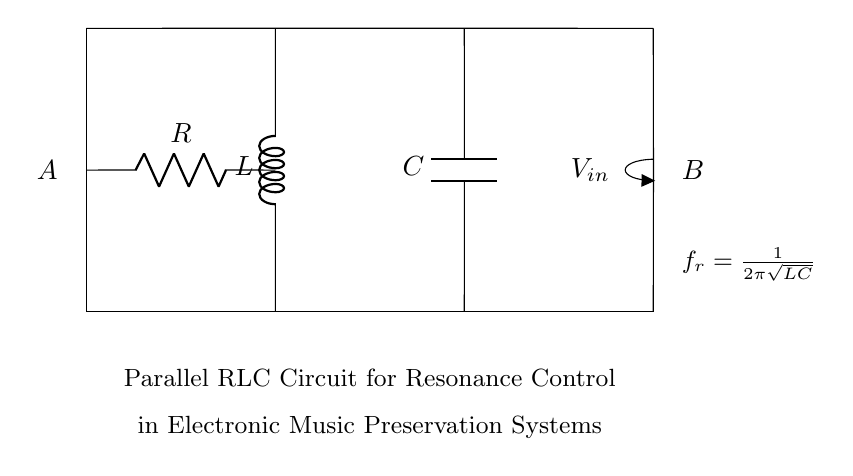What components are present in the circuit? The circuit contains a resistor, an inductor, and a capacitor, which are the standard components found in a parallel RLC circuit configuration.
Answer: Resistor, Inductor, Capacitor What is the input voltage represented in the diagram? The input voltage is denoted by the symbol V with a subscript 'in', which indicates the voltage applied across the circuit from point A to point B.
Answer: V in What is the resonant frequency formula indicated in the circuit? The formula for resonant frequency is expressed as one divided by two pi times the square root of the product of inductance and capacitance, indicating how the frequency depends on these two values.
Answer: f r = 1 / 2 π √(L C) How are the inductor and capacitor connected in this circuit? The inductor and capacitor are connected in parallel to each other, which is characteristic of RLC circuits used for resonance control, allowing the current to divide between them.
Answer: In parallel What is the significance of the resonant frequency in this circuit? The resonant frequency determines the frequency at which the circuit can oscillate at maximum amplitude, vital for tuning and resonance in electronic music preservation systems.
Answer: Maximum amplitude frequency What would happen if the resistance in the circuit is increased? Increasing the resistance would lower the peak current through the circuit, which can affect the quality and sharpness of the resonance, leading to less efficient energy transfer at the resonant frequency.
Answer: Lower peak current 